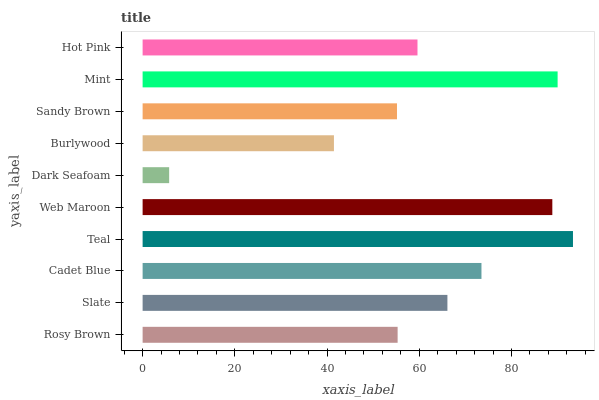Is Dark Seafoam the minimum?
Answer yes or no. Yes. Is Teal the maximum?
Answer yes or no. Yes. Is Slate the minimum?
Answer yes or no. No. Is Slate the maximum?
Answer yes or no. No. Is Slate greater than Rosy Brown?
Answer yes or no. Yes. Is Rosy Brown less than Slate?
Answer yes or no. Yes. Is Rosy Brown greater than Slate?
Answer yes or no. No. Is Slate less than Rosy Brown?
Answer yes or no. No. Is Slate the high median?
Answer yes or no. Yes. Is Hot Pink the low median?
Answer yes or no. Yes. Is Dark Seafoam the high median?
Answer yes or no. No. Is Sandy Brown the low median?
Answer yes or no. No. 